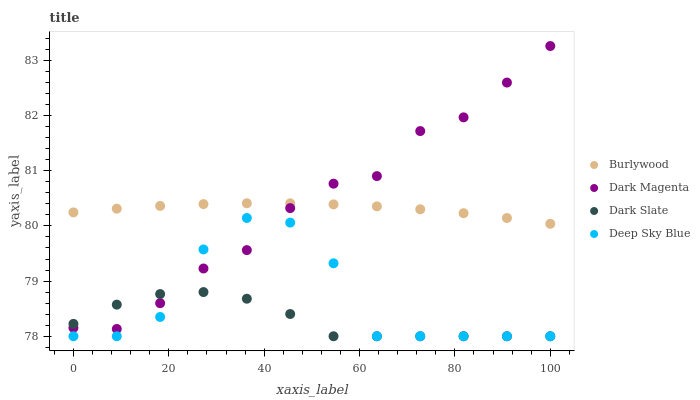Does Dark Slate have the minimum area under the curve?
Answer yes or no. Yes. Does Dark Magenta have the maximum area under the curve?
Answer yes or no. Yes. Does Dark Magenta have the minimum area under the curve?
Answer yes or no. No. Does Dark Slate have the maximum area under the curve?
Answer yes or no. No. Is Burlywood the smoothest?
Answer yes or no. Yes. Is Deep Sky Blue the roughest?
Answer yes or no. Yes. Is Dark Slate the smoothest?
Answer yes or no. No. Is Dark Slate the roughest?
Answer yes or no. No. Does Dark Slate have the lowest value?
Answer yes or no. Yes. Does Dark Magenta have the lowest value?
Answer yes or no. No. Does Dark Magenta have the highest value?
Answer yes or no. Yes. Does Dark Slate have the highest value?
Answer yes or no. No. Is Deep Sky Blue less than Burlywood?
Answer yes or no. Yes. Is Burlywood greater than Deep Sky Blue?
Answer yes or no. Yes. Does Dark Magenta intersect Burlywood?
Answer yes or no. Yes. Is Dark Magenta less than Burlywood?
Answer yes or no. No. Is Dark Magenta greater than Burlywood?
Answer yes or no. No. Does Deep Sky Blue intersect Burlywood?
Answer yes or no. No. 